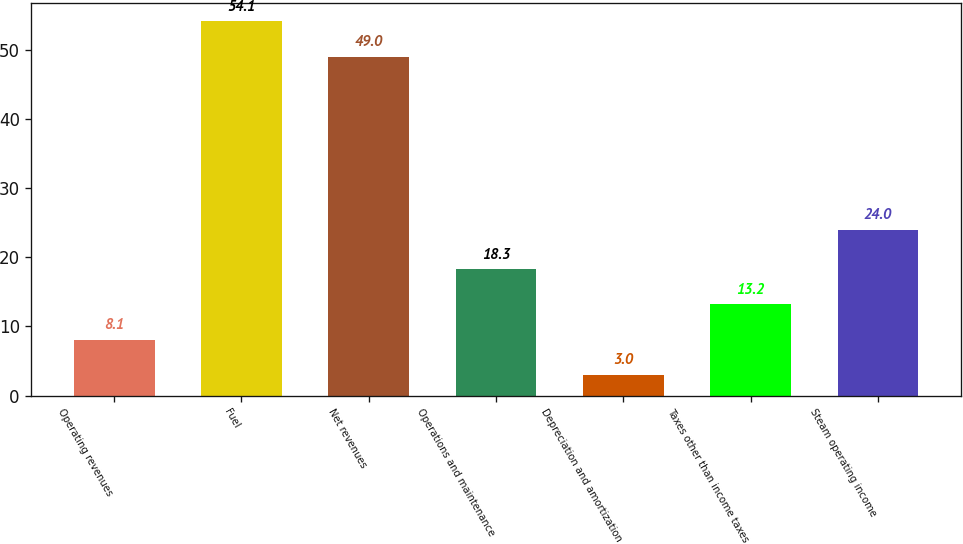<chart> <loc_0><loc_0><loc_500><loc_500><bar_chart><fcel>Operating revenues<fcel>Fuel<fcel>Net revenues<fcel>Operations and maintenance<fcel>Depreciation and amortization<fcel>Taxes other than income taxes<fcel>Steam operating income<nl><fcel>8.1<fcel>54.1<fcel>49<fcel>18.3<fcel>3<fcel>13.2<fcel>24<nl></chart> 